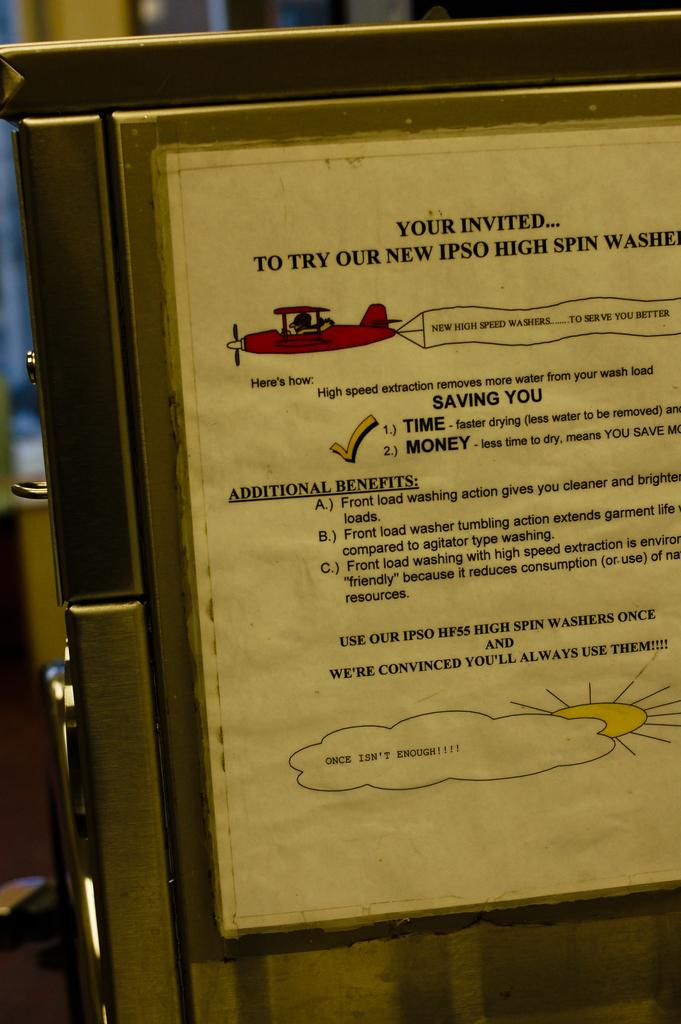What is the main object in the image? There is a board in the image. What is on the board? There is writing on the board. Can you describe the background of the image? The background of the image is blurred. How does the pollution affect the board in the image? There is no mention of pollution in the image, so it cannot be determined how it might affect the board. 